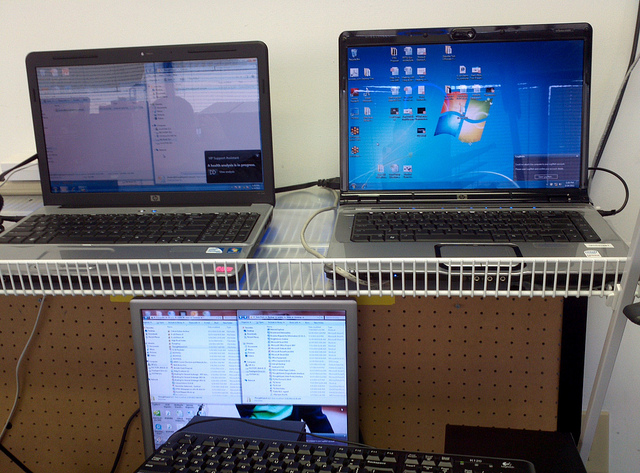How many screens do you see? There are three screens visible in the image, each showing a different desktop environment, indicating a multitasking setup that might be used for various computing tasks. 